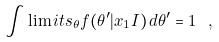<formula> <loc_0><loc_0><loc_500><loc_500>\int \lim i t s _ { \theta } f ( \theta ^ { \prime } | x _ { 1 } I ) \, d \theta ^ { \prime } = 1 \ ,</formula> 